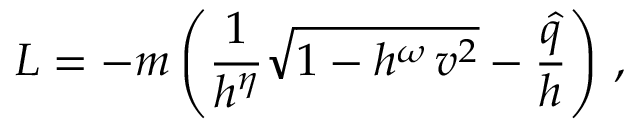Convert formula to latex. <formula><loc_0><loc_0><loc_500><loc_500>L = - m \left ( \frac { 1 } { h ^ { \eta } } \sqrt { 1 - h ^ { \omega } \, v ^ { 2 } } - \frac { \hat { q } } { h } \right ) \, ,</formula> 